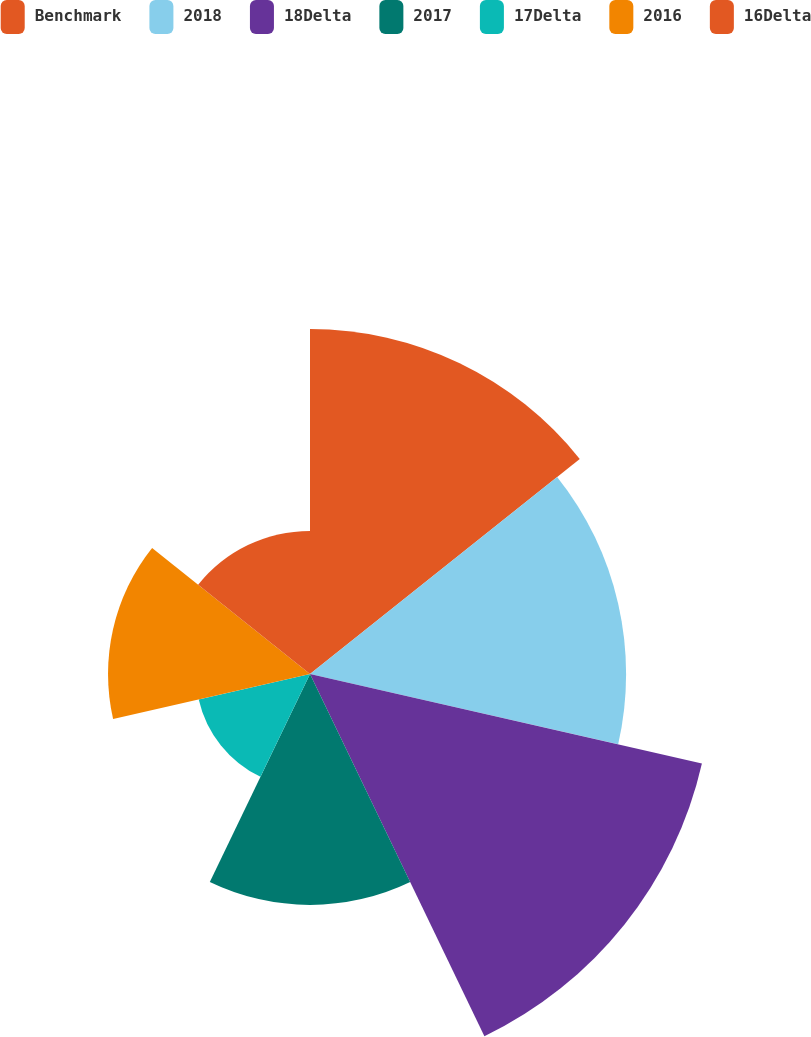Convert chart. <chart><loc_0><loc_0><loc_500><loc_500><pie_chart><fcel>Benchmark<fcel>2018<fcel>18Delta<fcel>2017<fcel>17Delta<fcel>2016<fcel>16Delta<nl><fcel>19.68%<fcel>18.03%<fcel>22.93%<fcel>13.17%<fcel>6.51%<fcel>11.52%<fcel>8.16%<nl></chart> 